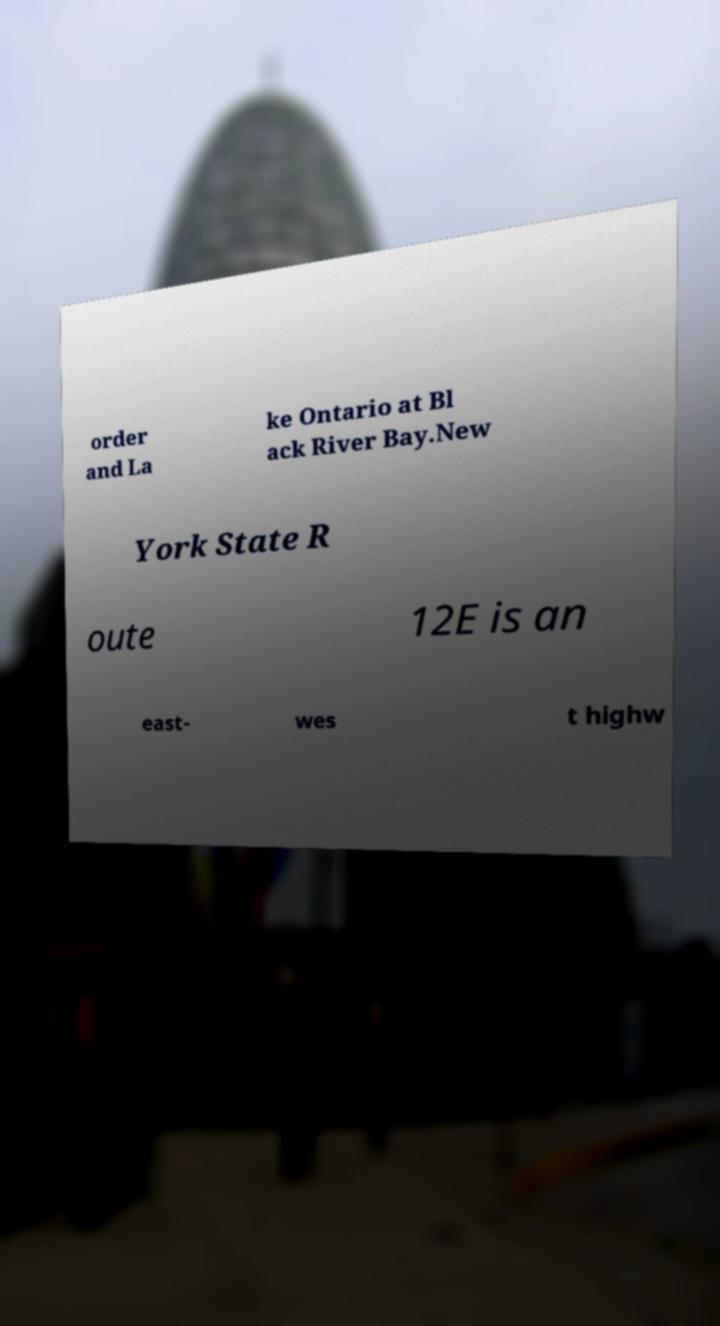Can you read and provide the text displayed in the image?This photo seems to have some interesting text. Can you extract and type it out for me? order and La ke Ontario at Bl ack River Bay.New York State R oute 12E is an east- wes t highw 